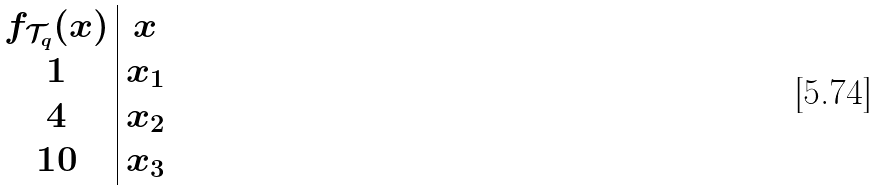Convert formula to latex. <formula><loc_0><loc_0><loc_500><loc_500>\begin{array} { c | c } f _ { \mathcal { T } _ { q } } ( x ) & x \\ 1 & x _ { 1 } \\ 4 & x _ { 2 } \\ 1 0 & x _ { 3 } \\ \end{array}</formula> 